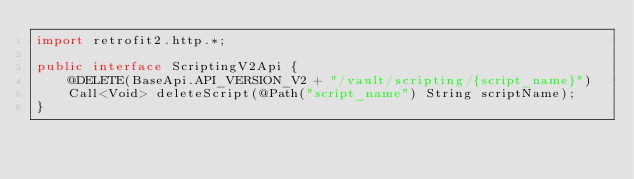<code> <loc_0><loc_0><loc_500><loc_500><_Java_>import retrofit2.http.*;

public interface ScriptingV2Api {
	@DELETE(BaseApi.API_VERSION_V2 + "/vault/scripting/{script_name}")
	Call<Void> deleteScript(@Path("script_name") String scriptName);
}
</code> 